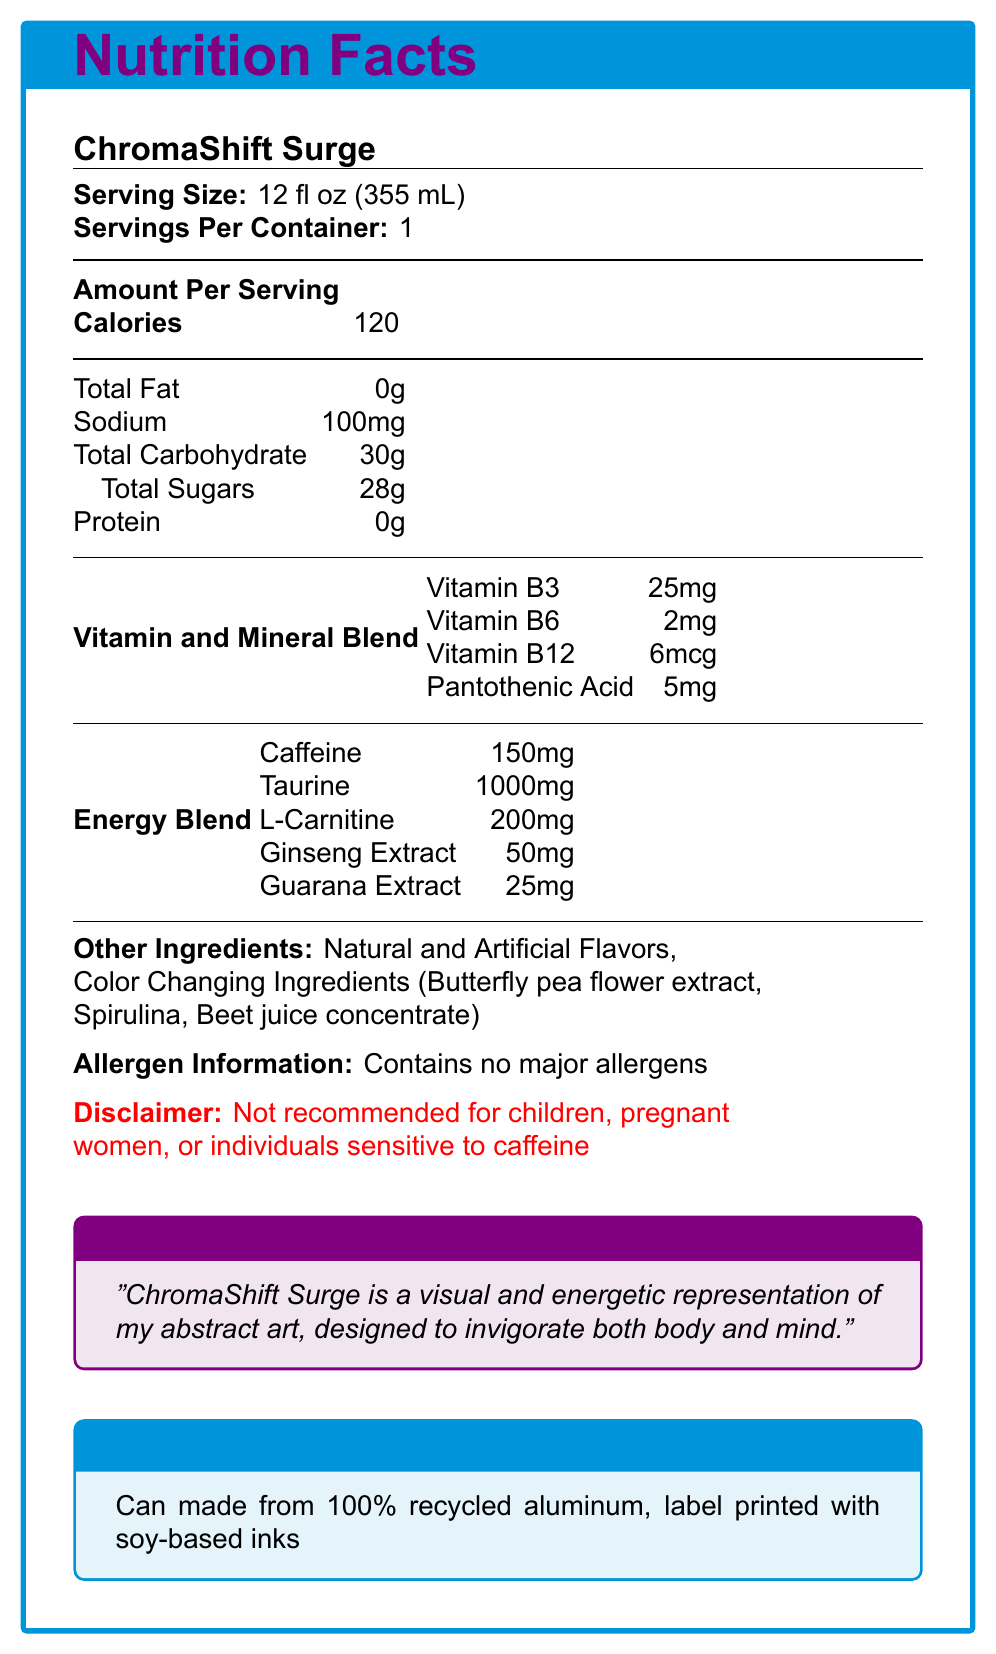What is the serving size? According to the document, the serving size of ChromaShift Surge is listed as 12 fl oz (355 mL).
Answer: 12 fl oz (355 mL) How many calories are in one serving of ChromaShift Surge? The document specifies that there are 120 calories per serving.
Answer: 120 What is the amount of caffeine per serving? The document lists the caffeine content as 150mg per serving.
Answer: 150mg Which vitamin has the highest amount per serving? The document shows that Vitamin B3 has the highest amount with 25mg per serving.
Answer: Vitamin B3 (25mg) Does the product contain any major allergens? Under "Allergen Information," the document states that the product contains no major allergens.
Answer: No Which of the following ingredients are part of the Color Changing Ingredients? 
A. Spirulina
B. Guarana Extract
C. Vitamin B6
D. Soy Protein According to the document, Spirulina is listed as one of the Color Changing Ingredients.
Answer: A. Spirulina Which energy-boosting ingredient is present in the highest quantity? 
I. Caffeine
II. Taurine
III. L-Carnitine
IV. Ginseng Extract With 1000mg, Taurine has the highest quantity among the energy-boosting ingredients listed.
Answer: II. Taurine Is this drink recommended for children or pregnant women? The disclaimer specifically states that the product is "Not recommended for children, pregnant women, or individuals sensitive to caffeine."
Answer: No Summarize the main idea of the document. The document provides detailed nutritional information, ingredient lists, and warnings. It also touches on the artistic inspiration behind the product, its suitability for certain activities, and its sustainable packaging.
Answer: ChromaShift Surge is a unique energy drink inspired by abstract art, containing no major allergens and featuring vibrant, color-changing ingredients. It combines various vitamins and energy-boosting compounds, and it is not recommended for certain groups. The product also emphasizes sustainability with recycled packaging. How much protein is in each serving? The document clearly states that each serving contains 0g of protein.
Answer: 0g What is the vitamin B12 content in ChromaShift Surge? The document lists vitamin B12 content as 6mcg per serving.
Answer: 6mcg How is the packaging described? The packaging is described as having a sleek, cylindrical can with a matte finish and color-changing abstract patterns when chilled.
Answer: Sleek, cylindrical can featuring a matte finish with swirling, abstract patterns that change color when chilled What is the recommended pairing for ChromaShift Surge? The document mentions that the drink is best enjoyed during activities such as viewing contemporary art or brainstorming sessions.
Answer: Best enjoyed while viewing contemporary art or during creative brainstorming sessions Which extracts are included in the energy blend besides Caffeine? The energy blend includes Taurine, L-Carnitine, Ginseng Extract, and Guarana Extract besides Caffeine.
Answer: Taurine, L-Carnitine, Ginseng Extract, Guarana Extract What is the total carbohydrate content per serving? The document specifies that the total carbohydrate content per serving is 30g.
Answer: 30g Where is the label printed? The document mentions that the label is printed with soy-based inks.
Answer: With soy-based inks How much sodium is in each serving of ChromaShift Surge? The document shows that each serving contains 100mg of sodium.
Answer: 100mg Who is the target audience for ChromaShift Surge according to the disclaimer? The disclaimer specifies these groups as not recommended to consume the product.
Answer: Not recommended for children, pregnant women, or individuals sensitive to caffeine What is the total content of natural and artificial flavors? The document states that the drink includes natural and artificial flavors without specifying the exact amount.
Answer: Included What kind of font is used in the document? The type of font used in the document is not information that can be visually determined from the provided nutrition facts label.
Answer: Cannot be determined 